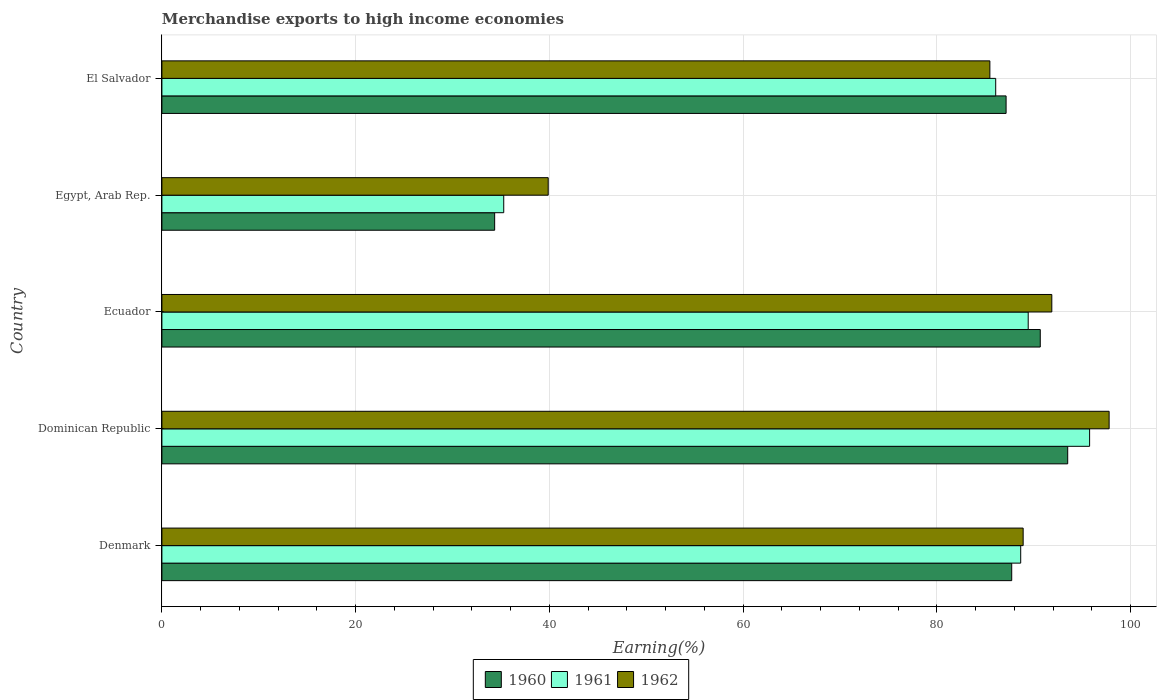How many different coloured bars are there?
Your answer should be very brief. 3. Are the number of bars on each tick of the Y-axis equal?
Give a very brief answer. Yes. How many bars are there on the 1st tick from the bottom?
Make the answer very short. 3. What is the label of the 1st group of bars from the top?
Provide a succinct answer. El Salvador. What is the percentage of amount earned from merchandise exports in 1960 in Denmark?
Offer a very short reply. 87.73. Across all countries, what is the maximum percentage of amount earned from merchandise exports in 1961?
Make the answer very short. 95.77. Across all countries, what is the minimum percentage of amount earned from merchandise exports in 1961?
Make the answer very short. 35.29. In which country was the percentage of amount earned from merchandise exports in 1961 maximum?
Offer a very short reply. Dominican Republic. In which country was the percentage of amount earned from merchandise exports in 1960 minimum?
Your response must be concise. Egypt, Arab Rep. What is the total percentage of amount earned from merchandise exports in 1960 in the graph?
Offer a terse response. 393.41. What is the difference between the percentage of amount earned from merchandise exports in 1961 in Denmark and that in El Salvador?
Make the answer very short. 2.58. What is the difference between the percentage of amount earned from merchandise exports in 1960 in Ecuador and the percentage of amount earned from merchandise exports in 1961 in Dominican Republic?
Ensure brevity in your answer.  -5.09. What is the average percentage of amount earned from merchandise exports in 1960 per country?
Make the answer very short. 78.68. What is the difference between the percentage of amount earned from merchandise exports in 1962 and percentage of amount earned from merchandise exports in 1960 in Denmark?
Give a very brief answer. 1.18. In how many countries, is the percentage of amount earned from merchandise exports in 1962 greater than 88 %?
Give a very brief answer. 3. What is the ratio of the percentage of amount earned from merchandise exports in 1960 in Ecuador to that in El Salvador?
Provide a succinct answer. 1.04. What is the difference between the highest and the second highest percentage of amount earned from merchandise exports in 1962?
Make the answer very short. 5.92. What is the difference between the highest and the lowest percentage of amount earned from merchandise exports in 1962?
Ensure brevity in your answer.  57.9. In how many countries, is the percentage of amount earned from merchandise exports in 1960 greater than the average percentage of amount earned from merchandise exports in 1960 taken over all countries?
Offer a terse response. 4. Is the sum of the percentage of amount earned from merchandise exports in 1960 in Denmark and Ecuador greater than the maximum percentage of amount earned from merchandise exports in 1961 across all countries?
Your answer should be compact. Yes. What does the 3rd bar from the top in Denmark represents?
Your answer should be compact. 1960. What does the 3rd bar from the bottom in Ecuador represents?
Keep it short and to the point. 1962. Does the graph contain any zero values?
Your response must be concise. No. Does the graph contain grids?
Make the answer very short. Yes. Where does the legend appear in the graph?
Give a very brief answer. Bottom center. What is the title of the graph?
Make the answer very short. Merchandise exports to high income economies. Does "2014" appear as one of the legend labels in the graph?
Keep it short and to the point. No. What is the label or title of the X-axis?
Your answer should be very brief. Earning(%). What is the label or title of the Y-axis?
Offer a very short reply. Country. What is the Earning(%) in 1960 in Denmark?
Your answer should be compact. 87.73. What is the Earning(%) of 1961 in Denmark?
Make the answer very short. 88.66. What is the Earning(%) in 1962 in Denmark?
Your response must be concise. 88.91. What is the Earning(%) of 1960 in Dominican Republic?
Your response must be concise. 93.51. What is the Earning(%) of 1961 in Dominican Republic?
Give a very brief answer. 95.77. What is the Earning(%) in 1962 in Dominican Republic?
Give a very brief answer. 97.78. What is the Earning(%) of 1960 in Ecuador?
Your answer should be very brief. 90.68. What is the Earning(%) of 1961 in Ecuador?
Keep it short and to the point. 89.43. What is the Earning(%) of 1962 in Ecuador?
Ensure brevity in your answer.  91.87. What is the Earning(%) in 1960 in Egypt, Arab Rep.?
Offer a very short reply. 34.35. What is the Earning(%) of 1961 in Egypt, Arab Rep.?
Your answer should be very brief. 35.29. What is the Earning(%) in 1962 in Egypt, Arab Rep.?
Provide a short and direct response. 39.88. What is the Earning(%) of 1960 in El Salvador?
Your answer should be compact. 87.15. What is the Earning(%) of 1961 in El Salvador?
Provide a succinct answer. 86.07. What is the Earning(%) in 1962 in El Salvador?
Provide a succinct answer. 85.47. Across all countries, what is the maximum Earning(%) of 1960?
Ensure brevity in your answer.  93.51. Across all countries, what is the maximum Earning(%) in 1961?
Your response must be concise. 95.77. Across all countries, what is the maximum Earning(%) of 1962?
Ensure brevity in your answer.  97.78. Across all countries, what is the minimum Earning(%) of 1960?
Provide a short and direct response. 34.35. Across all countries, what is the minimum Earning(%) of 1961?
Your answer should be very brief. 35.29. Across all countries, what is the minimum Earning(%) in 1962?
Your response must be concise. 39.88. What is the total Earning(%) of 1960 in the graph?
Make the answer very short. 393.41. What is the total Earning(%) of 1961 in the graph?
Provide a short and direct response. 395.22. What is the total Earning(%) of 1962 in the graph?
Provide a succinct answer. 403.91. What is the difference between the Earning(%) in 1960 in Denmark and that in Dominican Republic?
Your answer should be compact. -5.78. What is the difference between the Earning(%) of 1961 in Denmark and that in Dominican Republic?
Make the answer very short. -7.11. What is the difference between the Earning(%) of 1962 in Denmark and that in Dominican Republic?
Keep it short and to the point. -8.88. What is the difference between the Earning(%) of 1960 in Denmark and that in Ecuador?
Your answer should be very brief. -2.95. What is the difference between the Earning(%) in 1961 in Denmark and that in Ecuador?
Offer a terse response. -0.78. What is the difference between the Earning(%) of 1962 in Denmark and that in Ecuador?
Keep it short and to the point. -2.96. What is the difference between the Earning(%) of 1960 in Denmark and that in Egypt, Arab Rep.?
Offer a very short reply. 53.38. What is the difference between the Earning(%) in 1961 in Denmark and that in Egypt, Arab Rep.?
Keep it short and to the point. 53.37. What is the difference between the Earning(%) in 1962 in Denmark and that in Egypt, Arab Rep.?
Your answer should be compact. 49.03. What is the difference between the Earning(%) of 1960 in Denmark and that in El Salvador?
Your answer should be compact. 0.58. What is the difference between the Earning(%) in 1961 in Denmark and that in El Salvador?
Ensure brevity in your answer.  2.58. What is the difference between the Earning(%) of 1962 in Denmark and that in El Salvador?
Your response must be concise. 3.44. What is the difference between the Earning(%) in 1960 in Dominican Republic and that in Ecuador?
Ensure brevity in your answer.  2.83. What is the difference between the Earning(%) of 1961 in Dominican Republic and that in Ecuador?
Offer a terse response. 6.34. What is the difference between the Earning(%) of 1962 in Dominican Republic and that in Ecuador?
Your response must be concise. 5.92. What is the difference between the Earning(%) of 1960 in Dominican Republic and that in Egypt, Arab Rep.?
Offer a very short reply. 59.16. What is the difference between the Earning(%) in 1961 in Dominican Republic and that in Egypt, Arab Rep.?
Your answer should be compact. 60.48. What is the difference between the Earning(%) of 1962 in Dominican Republic and that in Egypt, Arab Rep.?
Your answer should be very brief. 57.9. What is the difference between the Earning(%) of 1960 in Dominican Republic and that in El Salvador?
Provide a succinct answer. 6.36. What is the difference between the Earning(%) in 1961 in Dominican Republic and that in El Salvador?
Give a very brief answer. 9.69. What is the difference between the Earning(%) in 1962 in Dominican Republic and that in El Salvador?
Offer a very short reply. 12.31. What is the difference between the Earning(%) of 1960 in Ecuador and that in Egypt, Arab Rep.?
Make the answer very short. 56.32. What is the difference between the Earning(%) in 1961 in Ecuador and that in Egypt, Arab Rep.?
Offer a terse response. 54.14. What is the difference between the Earning(%) in 1962 in Ecuador and that in Egypt, Arab Rep.?
Offer a very short reply. 51.99. What is the difference between the Earning(%) of 1960 in Ecuador and that in El Salvador?
Ensure brevity in your answer.  3.53. What is the difference between the Earning(%) in 1961 in Ecuador and that in El Salvador?
Keep it short and to the point. 3.36. What is the difference between the Earning(%) of 1962 in Ecuador and that in El Salvador?
Your answer should be compact. 6.39. What is the difference between the Earning(%) of 1960 in Egypt, Arab Rep. and that in El Salvador?
Provide a short and direct response. -52.8. What is the difference between the Earning(%) in 1961 in Egypt, Arab Rep. and that in El Salvador?
Ensure brevity in your answer.  -50.79. What is the difference between the Earning(%) of 1962 in Egypt, Arab Rep. and that in El Salvador?
Keep it short and to the point. -45.59. What is the difference between the Earning(%) of 1960 in Denmark and the Earning(%) of 1961 in Dominican Republic?
Provide a succinct answer. -8.04. What is the difference between the Earning(%) in 1960 in Denmark and the Earning(%) in 1962 in Dominican Republic?
Give a very brief answer. -10.06. What is the difference between the Earning(%) in 1961 in Denmark and the Earning(%) in 1962 in Dominican Republic?
Offer a very short reply. -9.13. What is the difference between the Earning(%) in 1960 in Denmark and the Earning(%) in 1961 in Ecuador?
Your answer should be compact. -1.7. What is the difference between the Earning(%) in 1960 in Denmark and the Earning(%) in 1962 in Ecuador?
Give a very brief answer. -4.14. What is the difference between the Earning(%) in 1961 in Denmark and the Earning(%) in 1962 in Ecuador?
Your answer should be compact. -3.21. What is the difference between the Earning(%) of 1960 in Denmark and the Earning(%) of 1961 in Egypt, Arab Rep.?
Give a very brief answer. 52.44. What is the difference between the Earning(%) in 1960 in Denmark and the Earning(%) in 1962 in Egypt, Arab Rep.?
Offer a very short reply. 47.85. What is the difference between the Earning(%) of 1961 in Denmark and the Earning(%) of 1962 in Egypt, Arab Rep.?
Your answer should be very brief. 48.78. What is the difference between the Earning(%) in 1960 in Denmark and the Earning(%) in 1961 in El Salvador?
Offer a terse response. 1.65. What is the difference between the Earning(%) in 1960 in Denmark and the Earning(%) in 1962 in El Salvador?
Keep it short and to the point. 2.26. What is the difference between the Earning(%) of 1961 in Denmark and the Earning(%) of 1962 in El Salvador?
Provide a succinct answer. 3.18. What is the difference between the Earning(%) in 1960 in Dominican Republic and the Earning(%) in 1961 in Ecuador?
Provide a succinct answer. 4.08. What is the difference between the Earning(%) in 1960 in Dominican Republic and the Earning(%) in 1962 in Ecuador?
Your answer should be very brief. 1.64. What is the difference between the Earning(%) of 1961 in Dominican Republic and the Earning(%) of 1962 in Ecuador?
Provide a short and direct response. 3.9. What is the difference between the Earning(%) of 1960 in Dominican Republic and the Earning(%) of 1961 in Egypt, Arab Rep.?
Offer a very short reply. 58.22. What is the difference between the Earning(%) in 1960 in Dominican Republic and the Earning(%) in 1962 in Egypt, Arab Rep.?
Keep it short and to the point. 53.63. What is the difference between the Earning(%) of 1961 in Dominican Republic and the Earning(%) of 1962 in Egypt, Arab Rep.?
Offer a very short reply. 55.89. What is the difference between the Earning(%) in 1960 in Dominican Republic and the Earning(%) in 1961 in El Salvador?
Offer a very short reply. 7.43. What is the difference between the Earning(%) of 1960 in Dominican Republic and the Earning(%) of 1962 in El Salvador?
Offer a terse response. 8.03. What is the difference between the Earning(%) of 1961 in Dominican Republic and the Earning(%) of 1962 in El Salvador?
Provide a short and direct response. 10.3. What is the difference between the Earning(%) in 1960 in Ecuador and the Earning(%) in 1961 in Egypt, Arab Rep.?
Offer a terse response. 55.39. What is the difference between the Earning(%) in 1960 in Ecuador and the Earning(%) in 1962 in Egypt, Arab Rep.?
Your answer should be compact. 50.8. What is the difference between the Earning(%) of 1961 in Ecuador and the Earning(%) of 1962 in Egypt, Arab Rep.?
Offer a very short reply. 49.55. What is the difference between the Earning(%) of 1960 in Ecuador and the Earning(%) of 1961 in El Salvador?
Your answer should be compact. 4.6. What is the difference between the Earning(%) in 1960 in Ecuador and the Earning(%) in 1962 in El Salvador?
Offer a terse response. 5.2. What is the difference between the Earning(%) of 1961 in Ecuador and the Earning(%) of 1962 in El Salvador?
Provide a succinct answer. 3.96. What is the difference between the Earning(%) in 1960 in Egypt, Arab Rep. and the Earning(%) in 1961 in El Salvador?
Your answer should be very brief. -51.72. What is the difference between the Earning(%) in 1960 in Egypt, Arab Rep. and the Earning(%) in 1962 in El Salvador?
Give a very brief answer. -51.12. What is the difference between the Earning(%) in 1961 in Egypt, Arab Rep. and the Earning(%) in 1962 in El Salvador?
Offer a very short reply. -50.19. What is the average Earning(%) of 1960 per country?
Give a very brief answer. 78.68. What is the average Earning(%) of 1961 per country?
Your answer should be compact. 79.04. What is the average Earning(%) of 1962 per country?
Offer a terse response. 80.78. What is the difference between the Earning(%) of 1960 and Earning(%) of 1961 in Denmark?
Provide a short and direct response. -0.93. What is the difference between the Earning(%) of 1960 and Earning(%) of 1962 in Denmark?
Your answer should be very brief. -1.18. What is the difference between the Earning(%) of 1961 and Earning(%) of 1962 in Denmark?
Ensure brevity in your answer.  -0.25. What is the difference between the Earning(%) of 1960 and Earning(%) of 1961 in Dominican Republic?
Provide a succinct answer. -2.26. What is the difference between the Earning(%) in 1960 and Earning(%) in 1962 in Dominican Republic?
Provide a short and direct response. -4.28. What is the difference between the Earning(%) in 1961 and Earning(%) in 1962 in Dominican Republic?
Provide a short and direct response. -2.02. What is the difference between the Earning(%) of 1960 and Earning(%) of 1961 in Ecuador?
Your response must be concise. 1.25. What is the difference between the Earning(%) of 1960 and Earning(%) of 1962 in Ecuador?
Your answer should be very brief. -1.19. What is the difference between the Earning(%) of 1961 and Earning(%) of 1962 in Ecuador?
Your answer should be very brief. -2.44. What is the difference between the Earning(%) of 1960 and Earning(%) of 1961 in Egypt, Arab Rep.?
Give a very brief answer. -0.94. What is the difference between the Earning(%) in 1960 and Earning(%) in 1962 in Egypt, Arab Rep.?
Make the answer very short. -5.53. What is the difference between the Earning(%) of 1961 and Earning(%) of 1962 in Egypt, Arab Rep.?
Keep it short and to the point. -4.59. What is the difference between the Earning(%) in 1960 and Earning(%) in 1961 in El Salvador?
Your answer should be very brief. 1.07. What is the difference between the Earning(%) in 1960 and Earning(%) in 1962 in El Salvador?
Make the answer very short. 1.67. What is the difference between the Earning(%) in 1961 and Earning(%) in 1962 in El Salvador?
Make the answer very short. 0.6. What is the ratio of the Earning(%) in 1960 in Denmark to that in Dominican Republic?
Ensure brevity in your answer.  0.94. What is the ratio of the Earning(%) in 1961 in Denmark to that in Dominican Republic?
Offer a very short reply. 0.93. What is the ratio of the Earning(%) in 1962 in Denmark to that in Dominican Republic?
Offer a very short reply. 0.91. What is the ratio of the Earning(%) in 1960 in Denmark to that in Ecuador?
Offer a terse response. 0.97. What is the ratio of the Earning(%) in 1961 in Denmark to that in Ecuador?
Provide a succinct answer. 0.99. What is the ratio of the Earning(%) of 1962 in Denmark to that in Ecuador?
Your answer should be compact. 0.97. What is the ratio of the Earning(%) in 1960 in Denmark to that in Egypt, Arab Rep.?
Your response must be concise. 2.55. What is the ratio of the Earning(%) of 1961 in Denmark to that in Egypt, Arab Rep.?
Your answer should be compact. 2.51. What is the ratio of the Earning(%) in 1962 in Denmark to that in Egypt, Arab Rep.?
Your response must be concise. 2.23. What is the ratio of the Earning(%) in 1961 in Denmark to that in El Salvador?
Provide a succinct answer. 1.03. What is the ratio of the Earning(%) of 1962 in Denmark to that in El Salvador?
Your answer should be very brief. 1.04. What is the ratio of the Earning(%) in 1960 in Dominican Republic to that in Ecuador?
Your answer should be compact. 1.03. What is the ratio of the Earning(%) in 1961 in Dominican Republic to that in Ecuador?
Your response must be concise. 1.07. What is the ratio of the Earning(%) in 1962 in Dominican Republic to that in Ecuador?
Give a very brief answer. 1.06. What is the ratio of the Earning(%) in 1960 in Dominican Republic to that in Egypt, Arab Rep.?
Keep it short and to the point. 2.72. What is the ratio of the Earning(%) of 1961 in Dominican Republic to that in Egypt, Arab Rep.?
Offer a very short reply. 2.71. What is the ratio of the Earning(%) in 1962 in Dominican Republic to that in Egypt, Arab Rep.?
Ensure brevity in your answer.  2.45. What is the ratio of the Earning(%) in 1960 in Dominican Republic to that in El Salvador?
Provide a short and direct response. 1.07. What is the ratio of the Earning(%) of 1961 in Dominican Republic to that in El Salvador?
Provide a short and direct response. 1.11. What is the ratio of the Earning(%) in 1962 in Dominican Republic to that in El Salvador?
Your answer should be compact. 1.14. What is the ratio of the Earning(%) of 1960 in Ecuador to that in Egypt, Arab Rep.?
Your answer should be very brief. 2.64. What is the ratio of the Earning(%) of 1961 in Ecuador to that in Egypt, Arab Rep.?
Keep it short and to the point. 2.53. What is the ratio of the Earning(%) in 1962 in Ecuador to that in Egypt, Arab Rep.?
Keep it short and to the point. 2.3. What is the ratio of the Earning(%) in 1960 in Ecuador to that in El Salvador?
Give a very brief answer. 1.04. What is the ratio of the Earning(%) of 1961 in Ecuador to that in El Salvador?
Provide a short and direct response. 1.04. What is the ratio of the Earning(%) in 1962 in Ecuador to that in El Salvador?
Provide a short and direct response. 1.07. What is the ratio of the Earning(%) in 1960 in Egypt, Arab Rep. to that in El Salvador?
Keep it short and to the point. 0.39. What is the ratio of the Earning(%) of 1961 in Egypt, Arab Rep. to that in El Salvador?
Make the answer very short. 0.41. What is the ratio of the Earning(%) in 1962 in Egypt, Arab Rep. to that in El Salvador?
Give a very brief answer. 0.47. What is the difference between the highest and the second highest Earning(%) in 1960?
Your response must be concise. 2.83. What is the difference between the highest and the second highest Earning(%) of 1961?
Give a very brief answer. 6.34. What is the difference between the highest and the second highest Earning(%) of 1962?
Offer a terse response. 5.92. What is the difference between the highest and the lowest Earning(%) of 1960?
Ensure brevity in your answer.  59.16. What is the difference between the highest and the lowest Earning(%) in 1961?
Keep it short and to the point. 60.48. What is the difference between the highest and the lowest Earning(%) of 1962?
Your response must be concise. 57.9. 